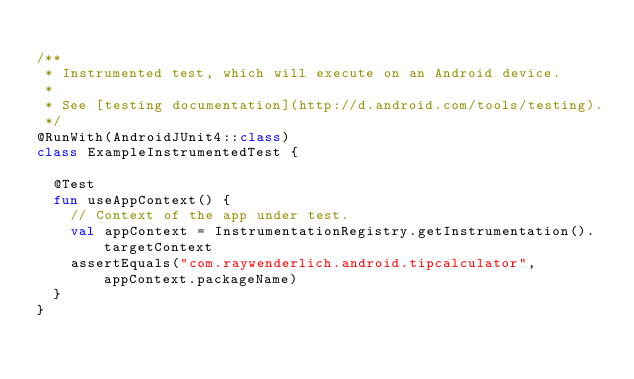Convert code to text. <code><loc_0><loc_0><loc_500><loc_500><_Kotlin_>
/**
 * Instrumented test, which will execute on an Android device.
 *
 * See [testing documentation](http://d.android.com/tools/testing).
 */
@RunWith(AndroidJUnit4::class)
class ExampleInstrumentedTest {

  @Test
  fun useAppContext() {
    // Context of the app under test.
    val appContext = InstrumentationRegistry.getInstrumentation().targetContext
    assertEquals("com.raywenderlich.android.tipcalculator", appContext.packageName)
  }
}
</code> 